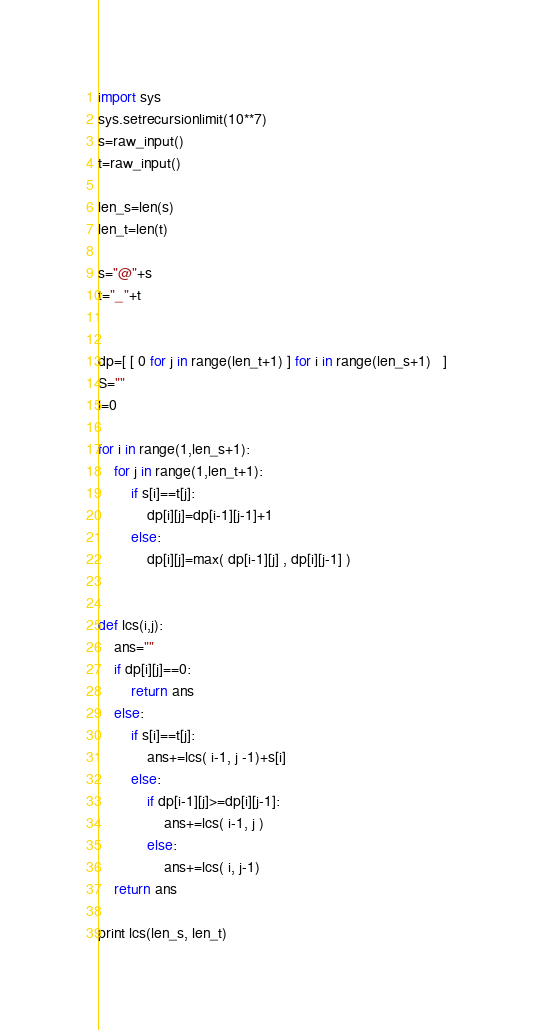Convert code to text. <code><loc_0><loc_0><loc_500><loc_500><_Python_>import sys
sys.setrecursionlimit(10**7)
s=raw_input()
t=raw_input()

len_s=len(s)
len_t=len(t)

s="@"+s
t="_"+t


dp=[ [ 0 for j in range(len_t+1) ] for i in range(len_s+1)   ]
S=""
l=0

for i in range(1,len_s+1):
	for j in range(1,len_t+1):
		if s[i]==t[j]:
			dp[i][j]=dp[i-1][j-1]+1
		else:			
			dp[i][j]=max( dp[i-1][j] , dp[i][j-1] )


def lcs(i,j):
	ans=""
	if dp[i][j]==0:
		return ans
	else:
		if s[i]==t[j]:
			ans+=lcs( i-1, j -1)+s[i]
		else:
			if dp[i-1][j]>=dp[i][j-1]:
				ans+=lcs( i-1, j )
			else:
				ans+=lcs( i, j-1)
	return ans

print lcs(len_s, len_t)

</code> 